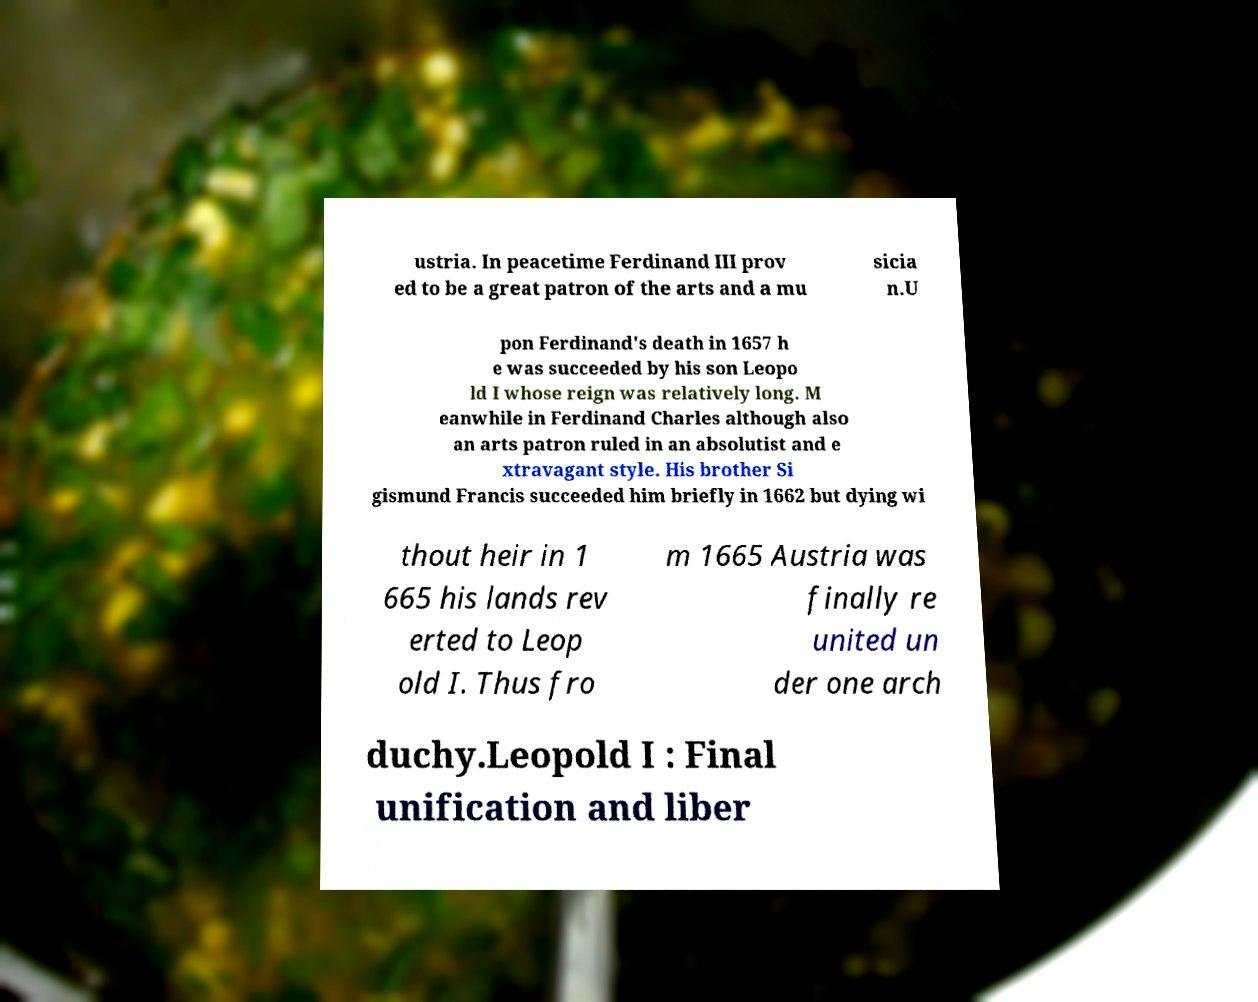Please identify and transcribe the text found in this image. ustria. In peacetime Ferdinand III prov ed to be a great patron of the arts and a mu sicia n.U pon Ferdinand's death in 1657 h e was succeeded by his son Leopo ld I whose reign was relatively long. M eanwhile in Ferdinand Charles although also an arts patron ruled in an absolutist and e xtravagant style. His brother Si gismund Francis succeeded him briefly in 1662 but dying wi thout heir in 1 665 his lands rev erted to Leop old I. Thus fro m 1665 Austria was finally re united un der one arch duchy.Leopold I : Final unification and liber 